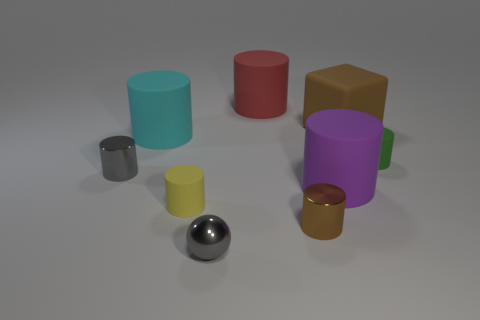The tiny metal thing that is the same color as the matte block is what shape?
Ensure brevity in your answer.  Cylinder. There is a shiny object behind the brown object that is in front of the small gray cylinder; what size is it?
Give a very brief answer. Small. Do the big thing on the left side of the shiny ball and the big object in front of the green cylinder have the same material?
Your response must be concise. Yes. There is a big cylinder that is both in front of the big block and right of the yellow cylinder; what material is it made of?
Give a very brief answer. Rubber. Do the cyan object and the small gray object on the right side of the tiny yellow cylinder have the same shape?
Ensure brevity in your answer.  No. What is the brown thing that is in front of the tiny cylinder that is to the right of the big rubber thing to the right of the purple rubber object made of?
Offer a terse response. Metal. How many other objects are the same size as the green object?
Offer a terse response. 4. How many things are on the right side of the cube on the right side of the large matte thing on the left side of the big red matte cylinder?
Your answer should be compact. 1. What material is the brown thing that is in front of the gray metallic object that is to the left of the big cyan cylinder?
Give a very brief answer. Metal. Is there a small green rubber thing of the same shape as the big cyan object?
Your answer should be very brief. Yes. 